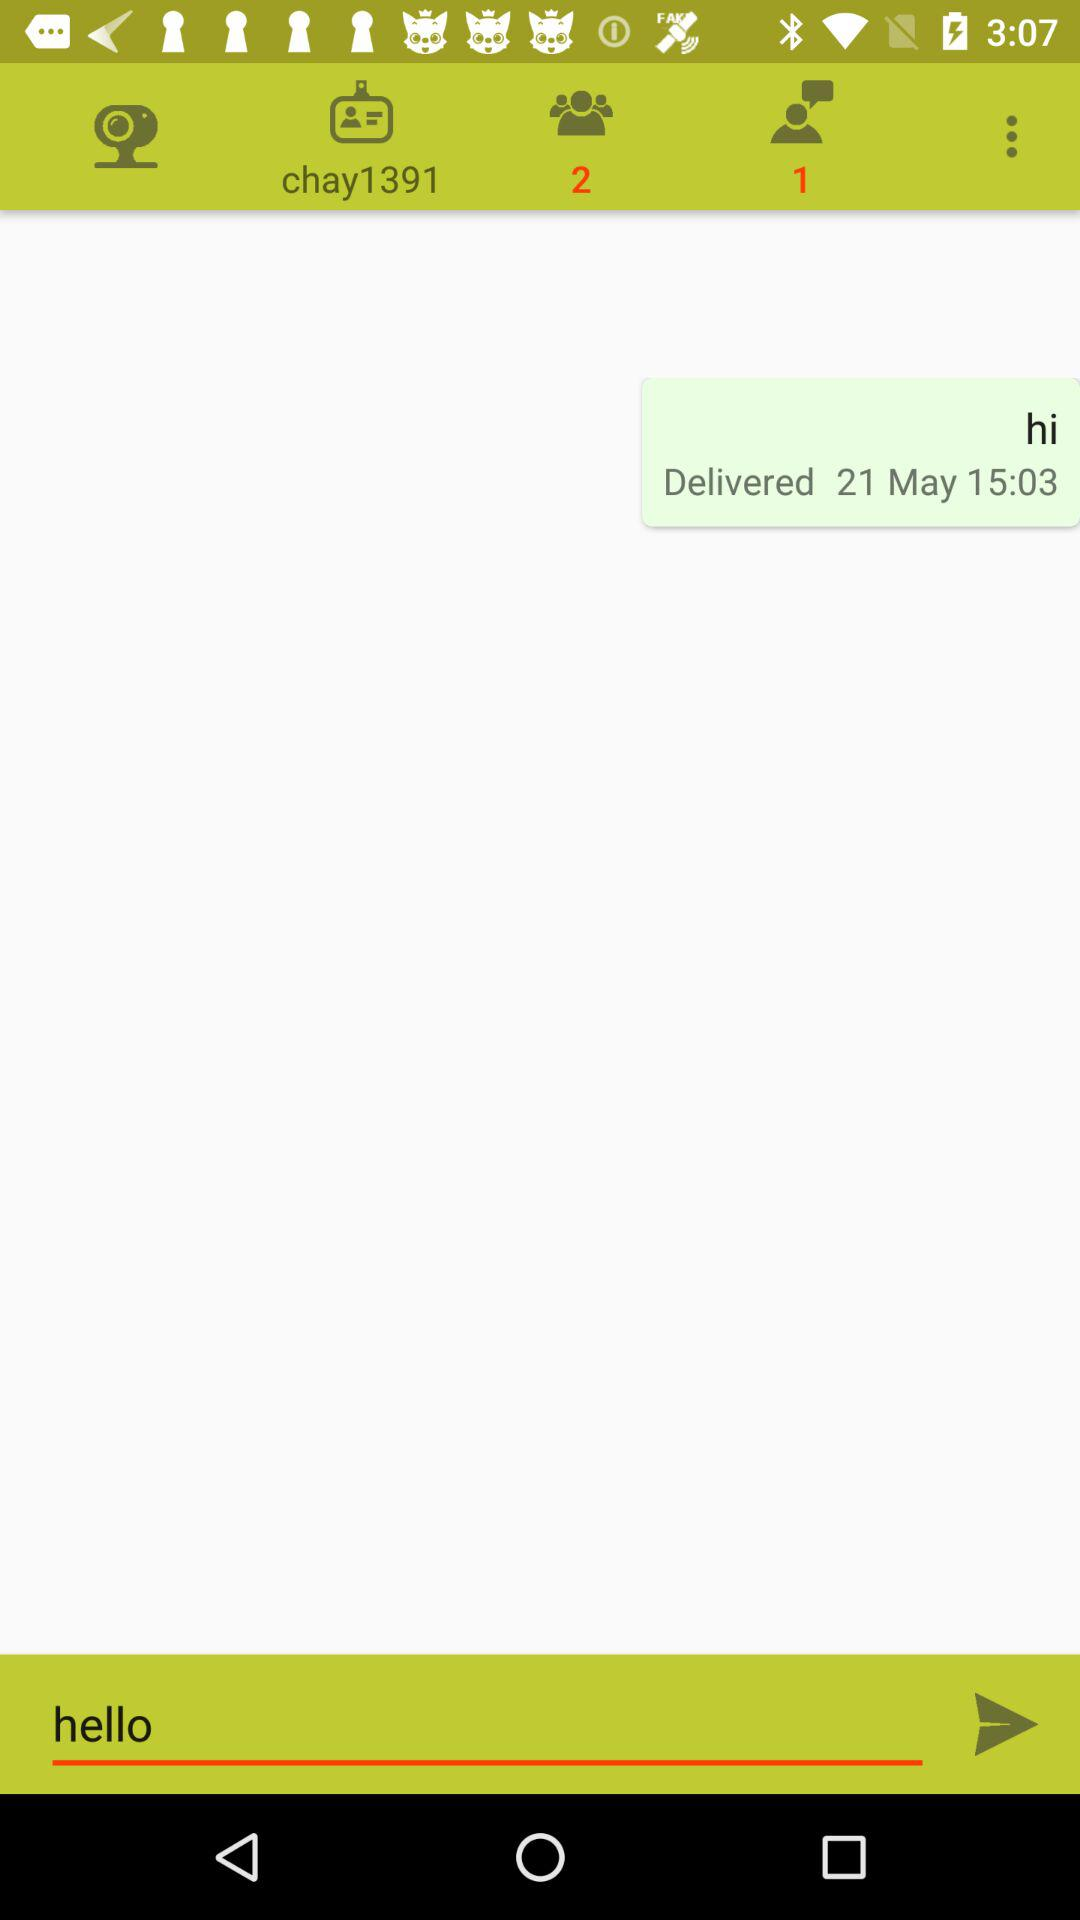What is the date of the last message? The date of the last message is May 21. 